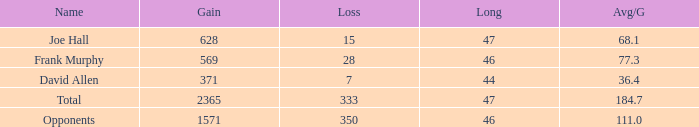What is the average gain per game for those with a gain less than 1571 and a long less than 46? 1.0. 